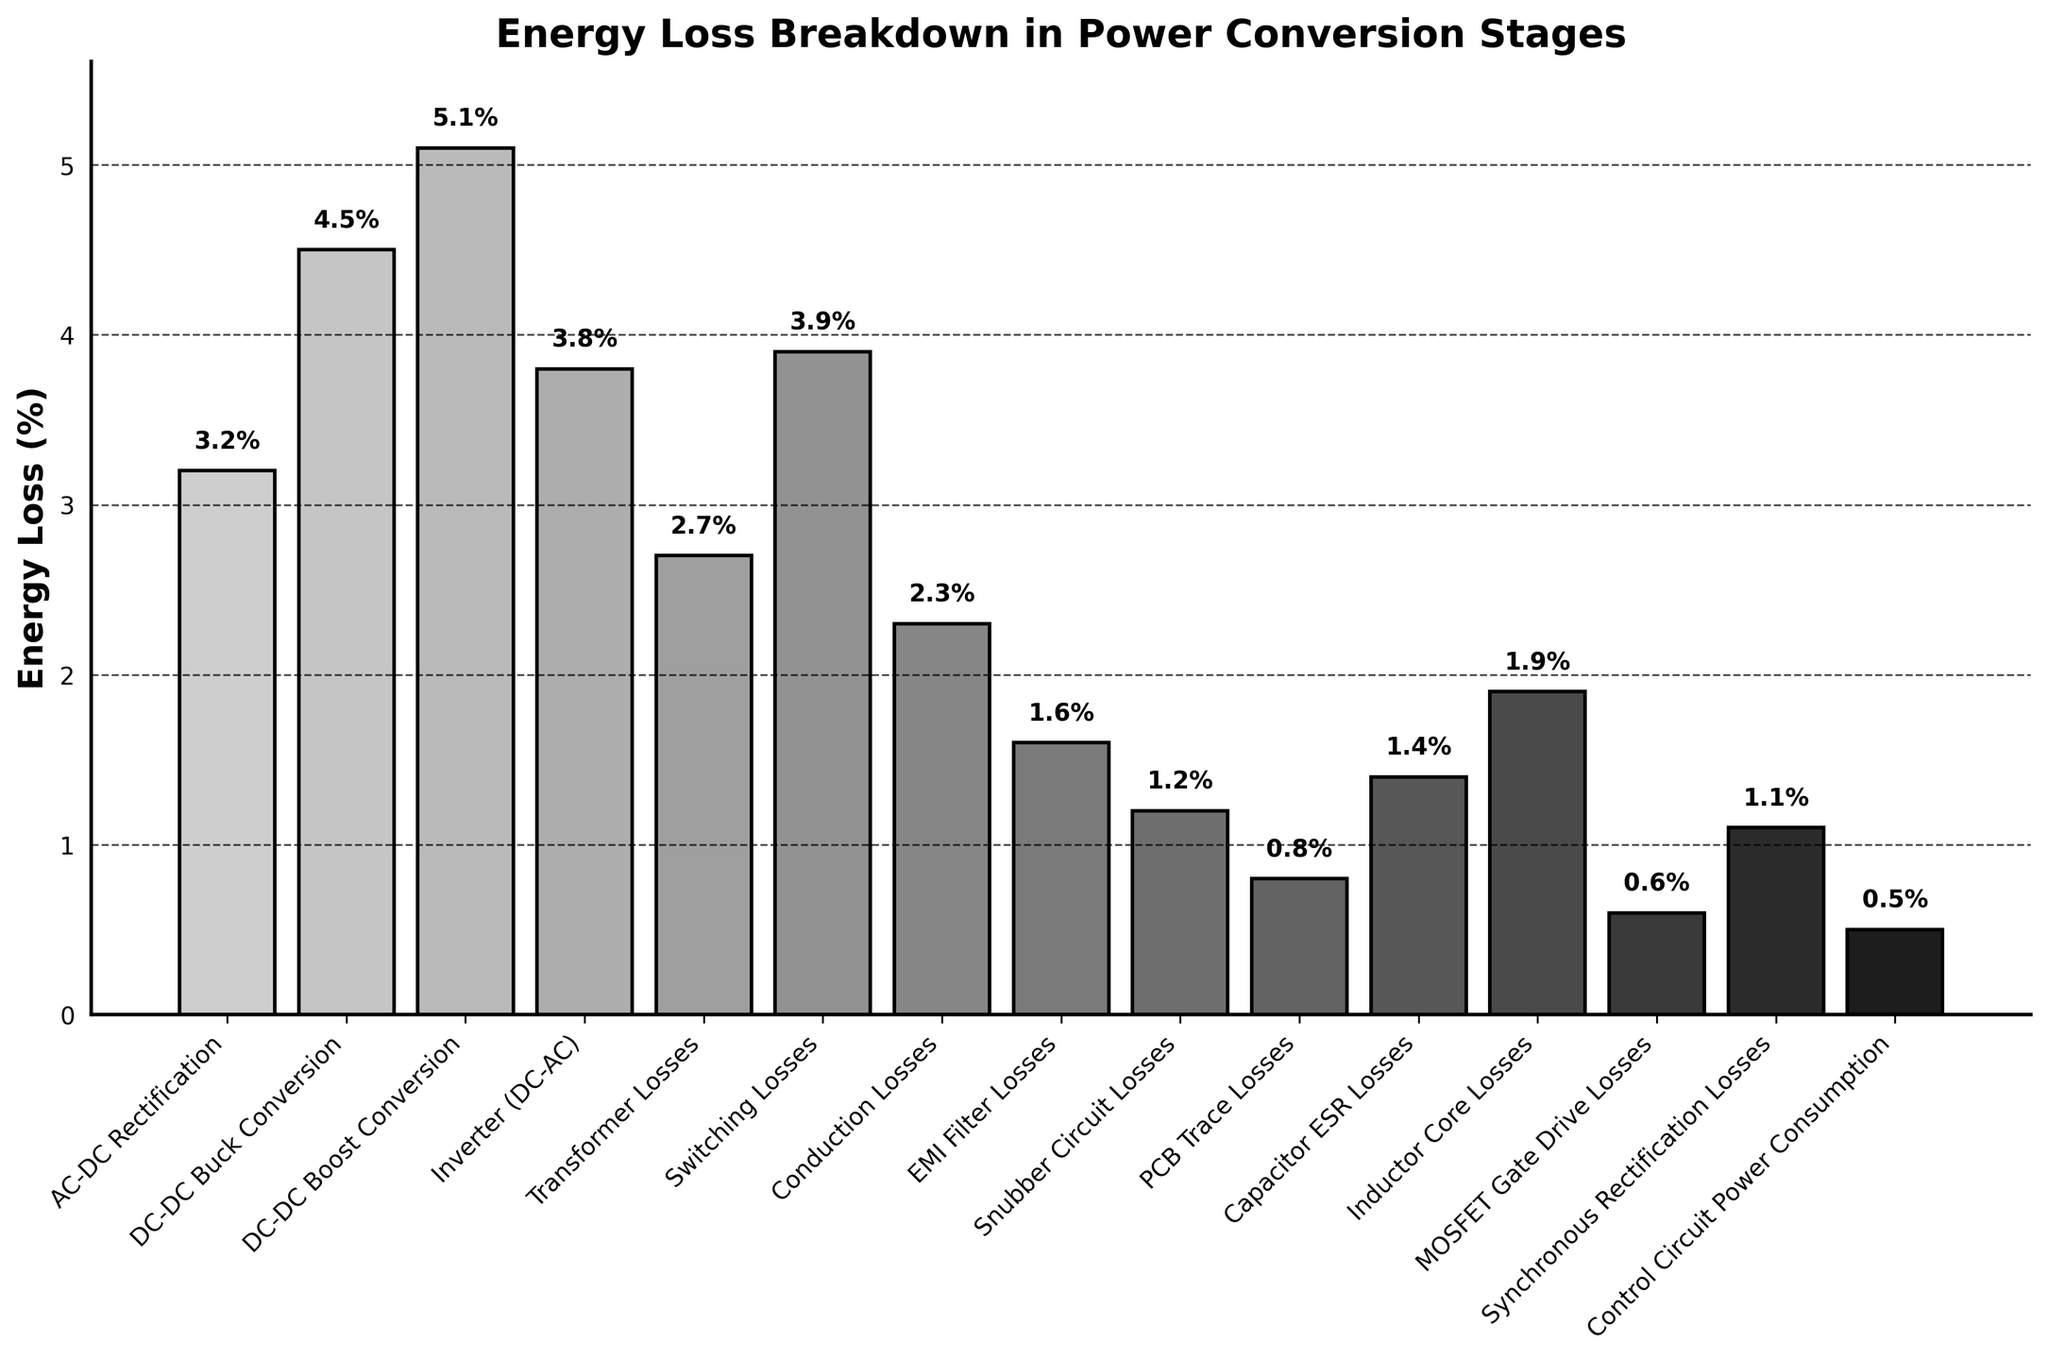How many stages have energy losses greater than 3 percent? Count the bars in the chart that represent energy losses greater than 3 percent. The stages are AC-DC Rectification, DC-DC Buck Conversion, DC-DC Boost Conversion, Inverter (DC-AC), and Switching Losses. These are 5 stages.
Answer: 5 Which stage has the highest energy loss? Identify the bar with the greatest height. The DC-DC Boost Conversion stage has the highest energy loss at 5.1%.
Answer: DC-DC Boost Conversion What is the total energy loss for AC-DC Rectification and Inverter (DC-AC) combined? Add the energy losses for AC-DC Rectification (3.2%) and Inverter (DC-AC) (3.8%). 3.2% + 3.8% = 7.0%.
Answer: 7.0% How much more energy loss is there in DC-DC Boost Conversion compared to EMI Filter Losses? Subtract the energy loss of EMI Filter Losses (1.6%) from DC-DC Boost Conversion (5.1%). 5.1% - 1.6% = 3.5%.
Answer: 3.5% What is the average energy loss across all the stages? Sum all the energy losses and divide by the number of stages. The total energy loss is 33.6% (i.e., 3.2 + 4.5 + 5.1 + 3.8 + 2.7 + 3.9 + 2.3 + 1.6 + 1.2 + 0.8 + 1.4 + 1.9 + 0.6 + 1.1 + 0.5). There are 15 stages. 33.6% / 15 = 2.24%.
Answer: 2.24% Which stages have energy losses less than 1 percent? Identify the bars that are shorter and below the 1% mark. The stages are PCB Trace Losses (0.8%), MOSFET Gate Drive Losses (0.6%), and Control Circuit Power Consumption (0.5%).
Answer: PCB Trace Losses, MOSFET Gate Drive Losses, Control Circuit Power Consumption What is the difference in energy loss between the highest and lowest loss stages? Subtract the smallest energy loss (Control Circuit Power Consumption at 0.5%) from the largest energy loss (DC-DC Boost Conversion at 5.1%). 5.1% - 0.5% = 4.6%.
Answer: 4.6% Which stage has the lowest energy loss and what is it? Identify the bar with the least height. The Control Circuit Power Consumption stage has the lowest energy loss at 0.5%.
Answer: Control Circuit Power Consumption, 0.5% How does the energy loss in Conduction Losses compare to Transformer Losses? Compare the height of the bars representing Conduction Losses (2.3%) and Transformer Losses (2.7%). The Conduction Losses are less than the Transformer Losses.
Answer: Less What are the combined energy losses of the stages related to DC-DC conversions (Buck and Boost)? Add the energy losses of DC-DC Buck Conversion (4.5%) and DC-DC Boost Conversion (5.1%). 4.5% + 5.1% = 9.6%.
Answer: 9.6% 